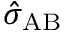<formula> <loc_0><loc_0><loc_500><loc_500>\hat { \sigma } _ { A B }</formula> 